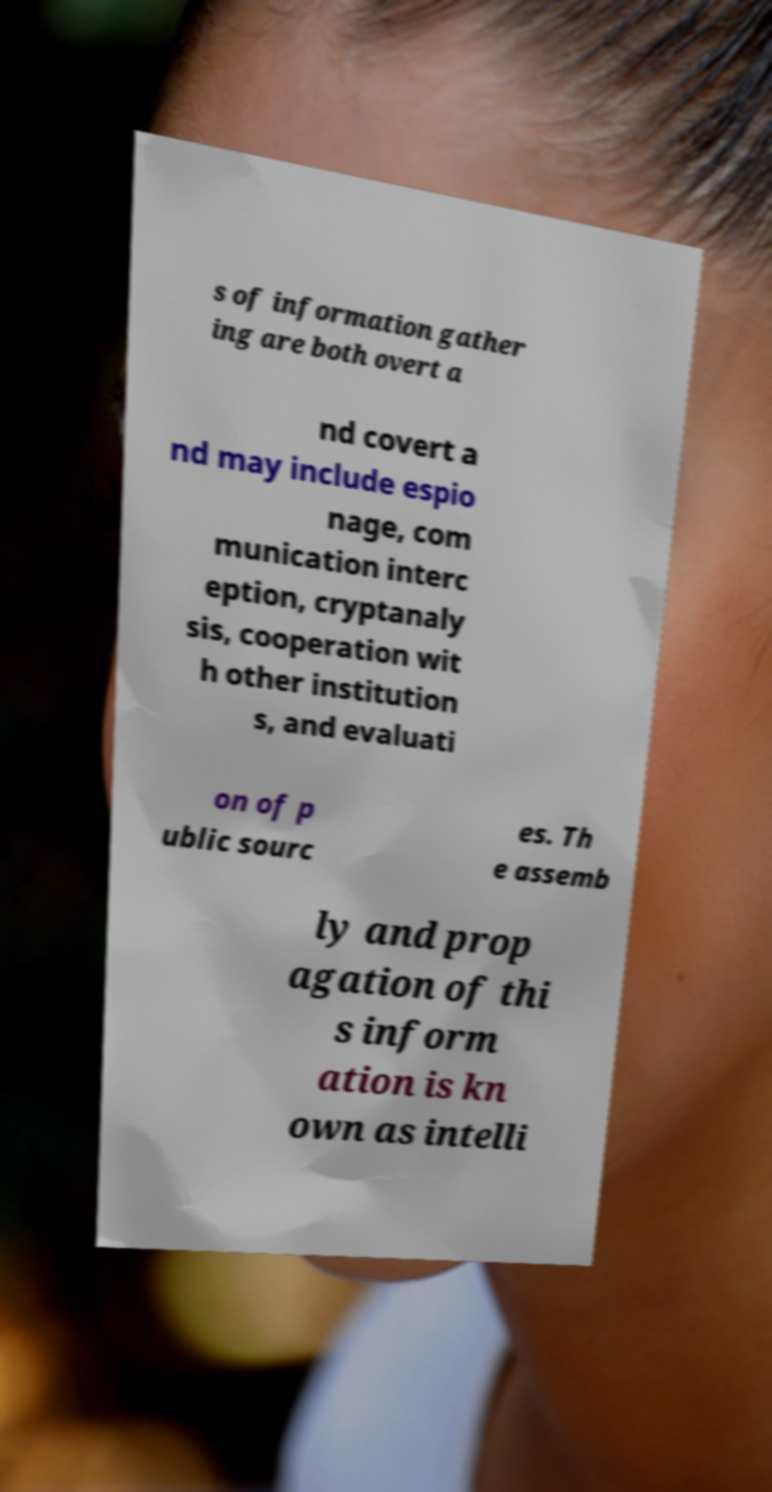Could you assist in decoding the text presented in this image and type it out clearly? s of information gather ing are both overt a nd covert a nd may include espio nage, com munication interc eption, cryptanaly sis, cooperation wit h other institution s, and evaluati on of p ublic sourc es. Th e assemb ly and prop agation of thi s inform ation is kn own as intelli 